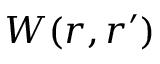<formula> <loc_0><loc_0><loc_500><loc_500>W ( r , r ^ { \prime } )</formula> 